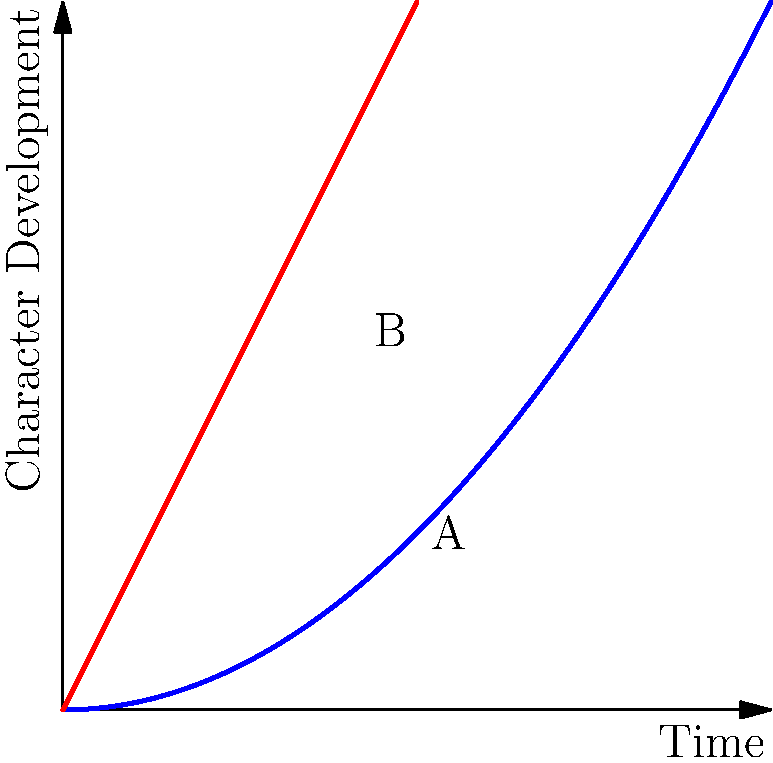In the character development arc shown, what is the approximate angle of inclination at point A compared to the linear growth line? How does this relate to the character's emotional journey? To analyze the angle of inclination in this character development arc:

1. Observe the blue curve representing the character arc and the red line showing linear growth.

2. Point A on the character arc is at (5, 2.5), while point B on the linear growth line is at (5, 5).

3. The angle of inclination at point A is the angle between the tangent line to the curve at A and the horizontal axis.

4. The curve's slope at A is steeper than at the beginning but less steep than the linear growth line.

5. Estimate the angle at A to be about 30°, while the linear growth line has a constant angle of 45°.

6. In character development terms:
   - The initial slow growth (small angle) represents the character's resistance to change.
   - The increasing angle at A shows accelerating growth, indicating the character is overcoming internal conflicts.
   - The curve's shape suggests a gradual build-up to a transformative moment.

7. Compared to linear growth, this arc demonstrates:
   - A more realistic and nuanced emotional journey.
   - Periods of slower and faster development, mirroring real-life personal growth.
   - A deeper, more satisfying character transformation over time.
Answer: Approximately 30°; represents accelerating emotional growth and overcoming internal conflicts. 